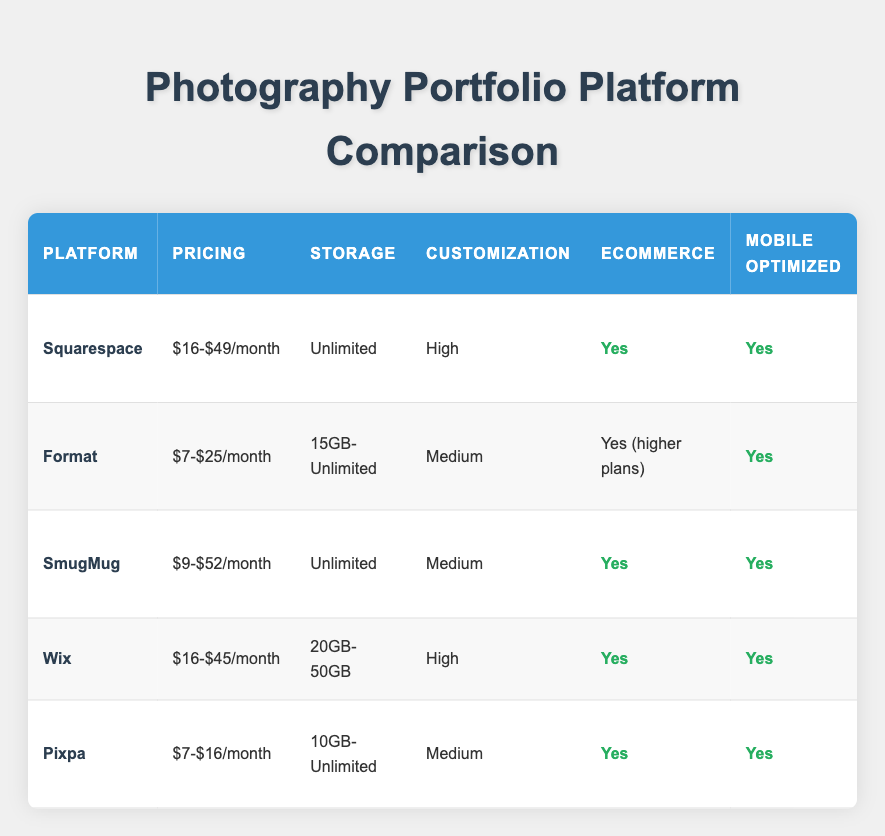What is the pricing range for Squarespace? The pricing for Squarespace is listed in the table as "$16-$49/month." This is a direct retrieval of the information from the "Pricing" column corresponding to Squarespace.
Answer: $16-$49/month Does Format include a domain with its plans? The table indicates that Format does not include a domain (indicated as "No" in the "Domain Included" column). This is a straightforward retrieval asking for a yes/no fact from the table.
Answer: No Which platform has the highest number of templates? Reviewing the "Templates" column, Wix has 800+ templates, which is the highest when compared to the other platforms listed. This is derived by comparing the numerical values of the templates across all platforms.
Answer: 800+ What is the average pricing of all the platforms listed? To find the average pricing, first convert each range into a midpoint: Squarespace ($32.5), Format ($16), SmugMug ($30.5), Wix ($30.5), and Pixpa ($11.5); now, sum these: 32.5 + 16 + 30.5 + 30.5 + 11.5 = 121 and divide by the number of platforms (5). Therefore, the average pricing is 121/5 = $24.2.
Answer: $24.2 Which platform provides 24/7 customer support? The platforms that have "24/7" listed under the "Customer Support" column are Squarespace and Wix (under higher plans). This question requires evaluating the customer support information across the platforms.
Answer: Squarespace, Wix How many platforms offer unlimited storage? The platforms that offer unlimited storage, as indicated in the "Storage" column, are Squarespace, SmugMug, and Pixpa. This requires counting the instances of "Unlimited" storage in the relevant column. There are three platforms in total.
Answer: 3 Is eCommerce available on all platforms? Looking at the "eCommerce" column, not all platforms have eCommerce included. Format only offers it on higher plans, while other platforms like Squarespace, SmugMug, Wix, and Pixpa offer it as standard. This is a yes/no evaluation based on the column data.
Answer: No What is the difference in storage between Wix and Format? Wix offers 20GB-50GB of storage while Format offers 15GB-Unlimited. The logical approach is determining the minimum storage from each: Wix (20GB) vs. Format (15GB); the difference is 20 - 15 = 5GB. Thus, Wix has a minimum of 5GB more than Format.
Answer: 5GB Which platform has advanced SEO options and includes a domain? The platforms with advanced SEO capabilities are Squarespace, Wix, and Pixpa. Among these, Squarespace and Wix also include a domain in their offerings. By examining the columns for both features, we find that both squarespace and Wix meet the criteria.
Answer: Squarespace, Wix 